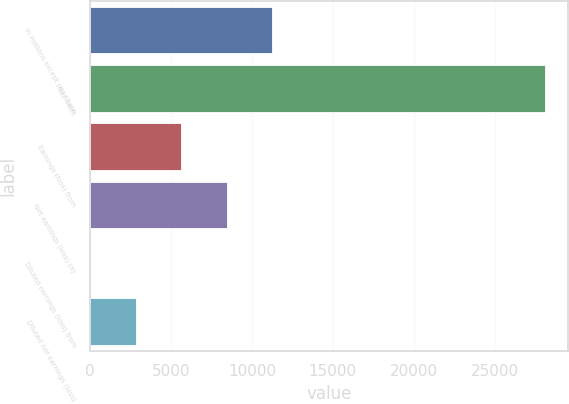<chart> <loc_0><loc_0><loc_500><loc_500><bar_chart><fcel>In millions except per share<fcel>Net sales<fcel>Earnings (loss) from<fcel>Net earnings (loss) (a)<fcel>Diluted earnings (loss) from<fcel>Diluted net earnings (loss)<nl><fcel>11251.1<fcel>28125<fcel>5626.46<fcel>8438.78<fcel>1.82<fcel>2814.14<nl></chart> 